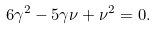<formula> <loc_0><loc_0><loc_500><loc_500>6 \gamma ^ { 2 } - 5 \gamma \nu + \nu ^ { 2 } = 0 .</formula> 